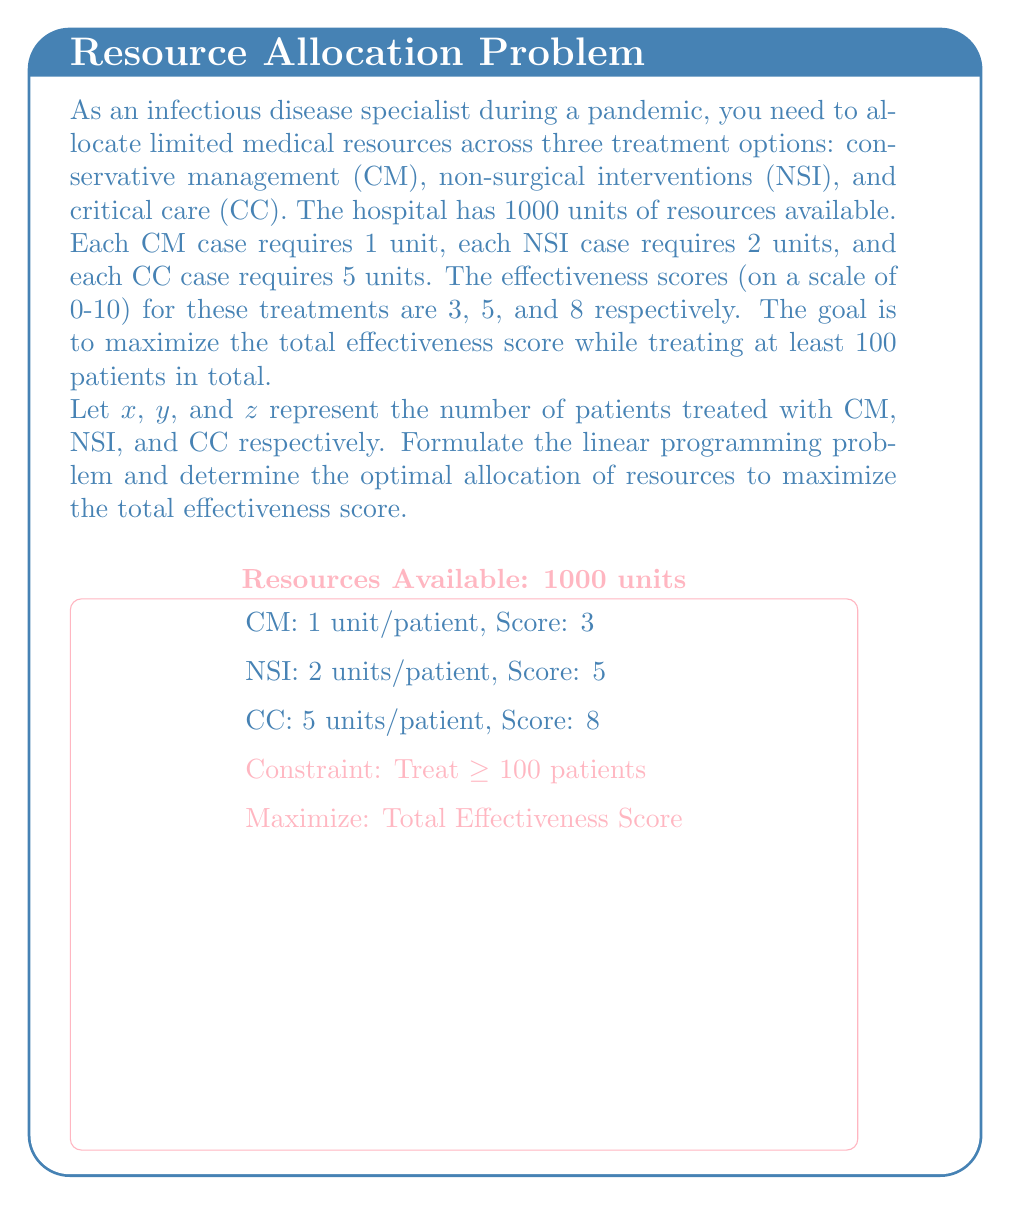What is the answer to this math problem? To solve this linear programming problem, we'll follow these steps:

1) Formulate the objective function:
   Maximize $Z = 3x + 5y + 8z$ (total effectiveness score)

2) Identify the constraints:
   a) Resource constraint: $x + 2y + 5z \leq 1000$
   b) Minimum patients treated: $x + y + z \geq 100$
   c) Non-negativity: $x, y, z \geq 0$

3) Set up the linear programming problem:
   Maximize $Z = 3x + 5y + 8z$
   Subject to:
   $x + 2y + 5z \leq 1000$
   $x + y + z \geq 100$
   $x, y, z \geq 0$

4) Solve using the simplex method or linear programming software. The optimal solution is:
   $x = 0$ (CM patients)
   $y = 50$ (NSI patients)
   $z = 180$ (CC patients)

5) Verify the solution:
   Resource usage: $0 + 2(50) + 5(180) = 1000$ units (meets constraint)
   Total patients: $0 + 50 + 180 = 230$ patients (exceeds minimum of 100)
   Total effectiveness score: $3(0) + 5(50) + 8(180) = 1690$

This allocation maximizes the total effectiveness score while meeting all constraints.
Answer: Optimal allocation: 0 CM, 50 NSI, 180 CC patients; Total score: 1690 